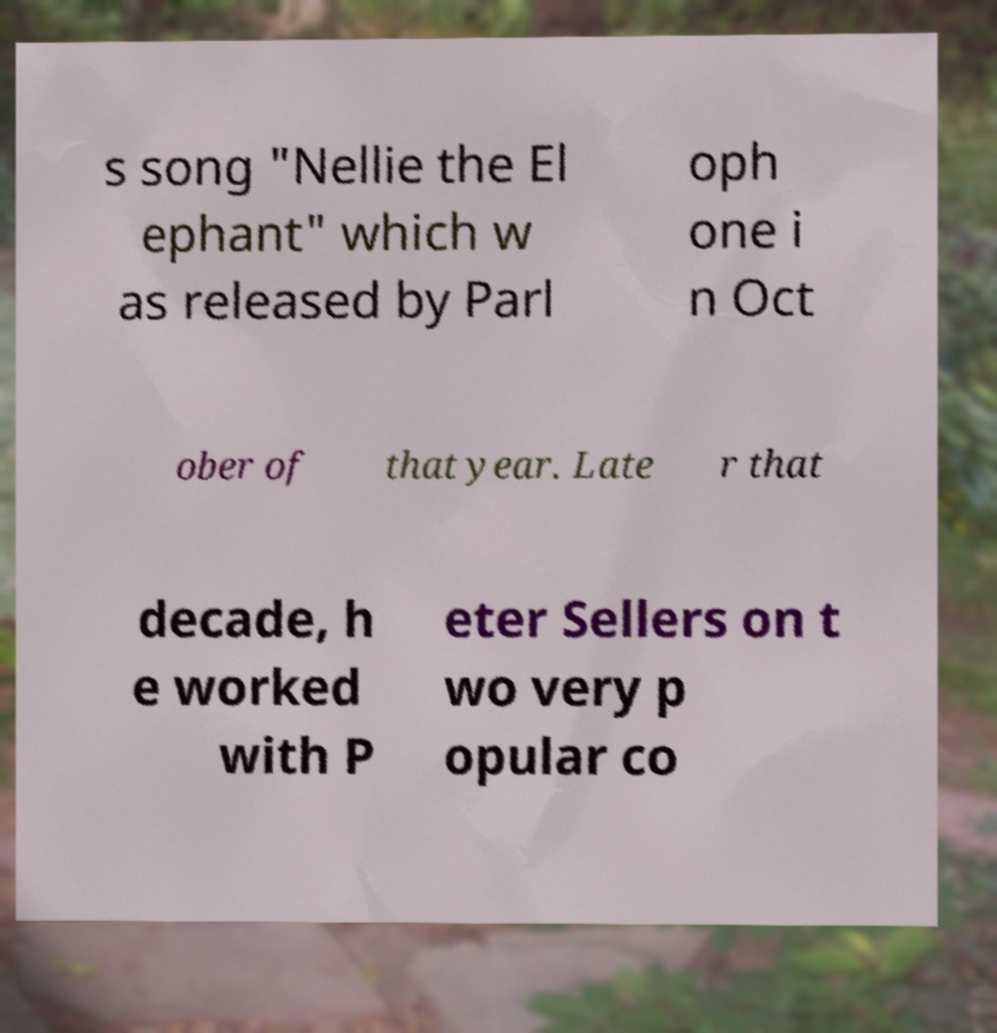Please identify and transcribe the text found in this image. s song "Nellie the El ephant" which w as released by Parl oph one i n Oct ober of that year. Late r that decade, h e worked with P eter Sellers on t wo very p opular co 